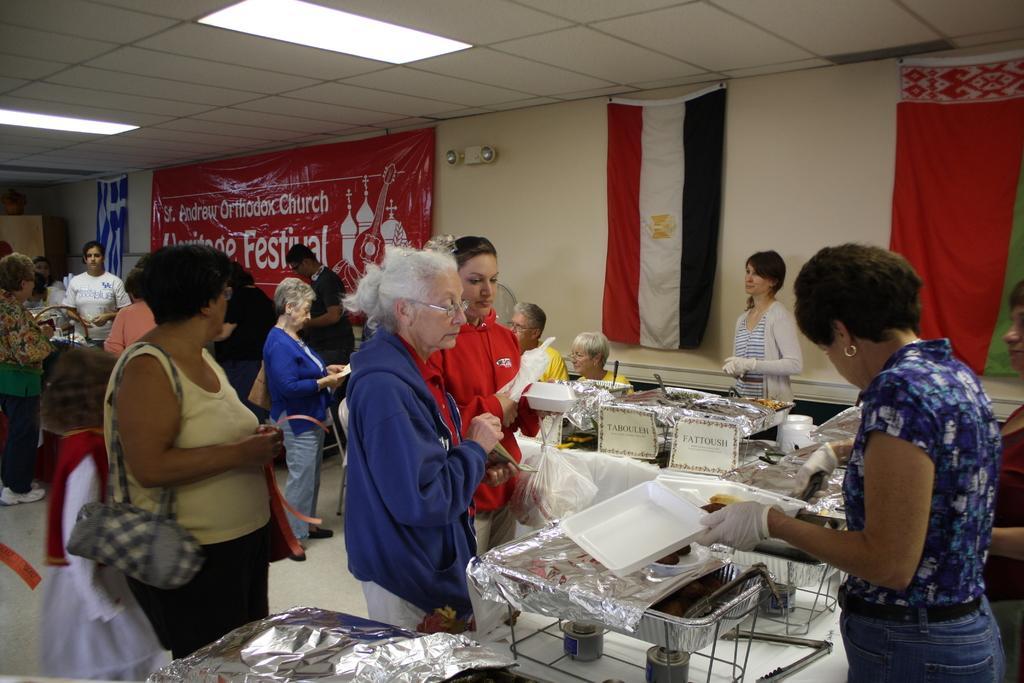Can you describe this image briefly? In this image we can see many persons standing on the floor. On the right side of the image we can see food items placed in a trays on the table. In the background we can see persons, flags and advertisements. 